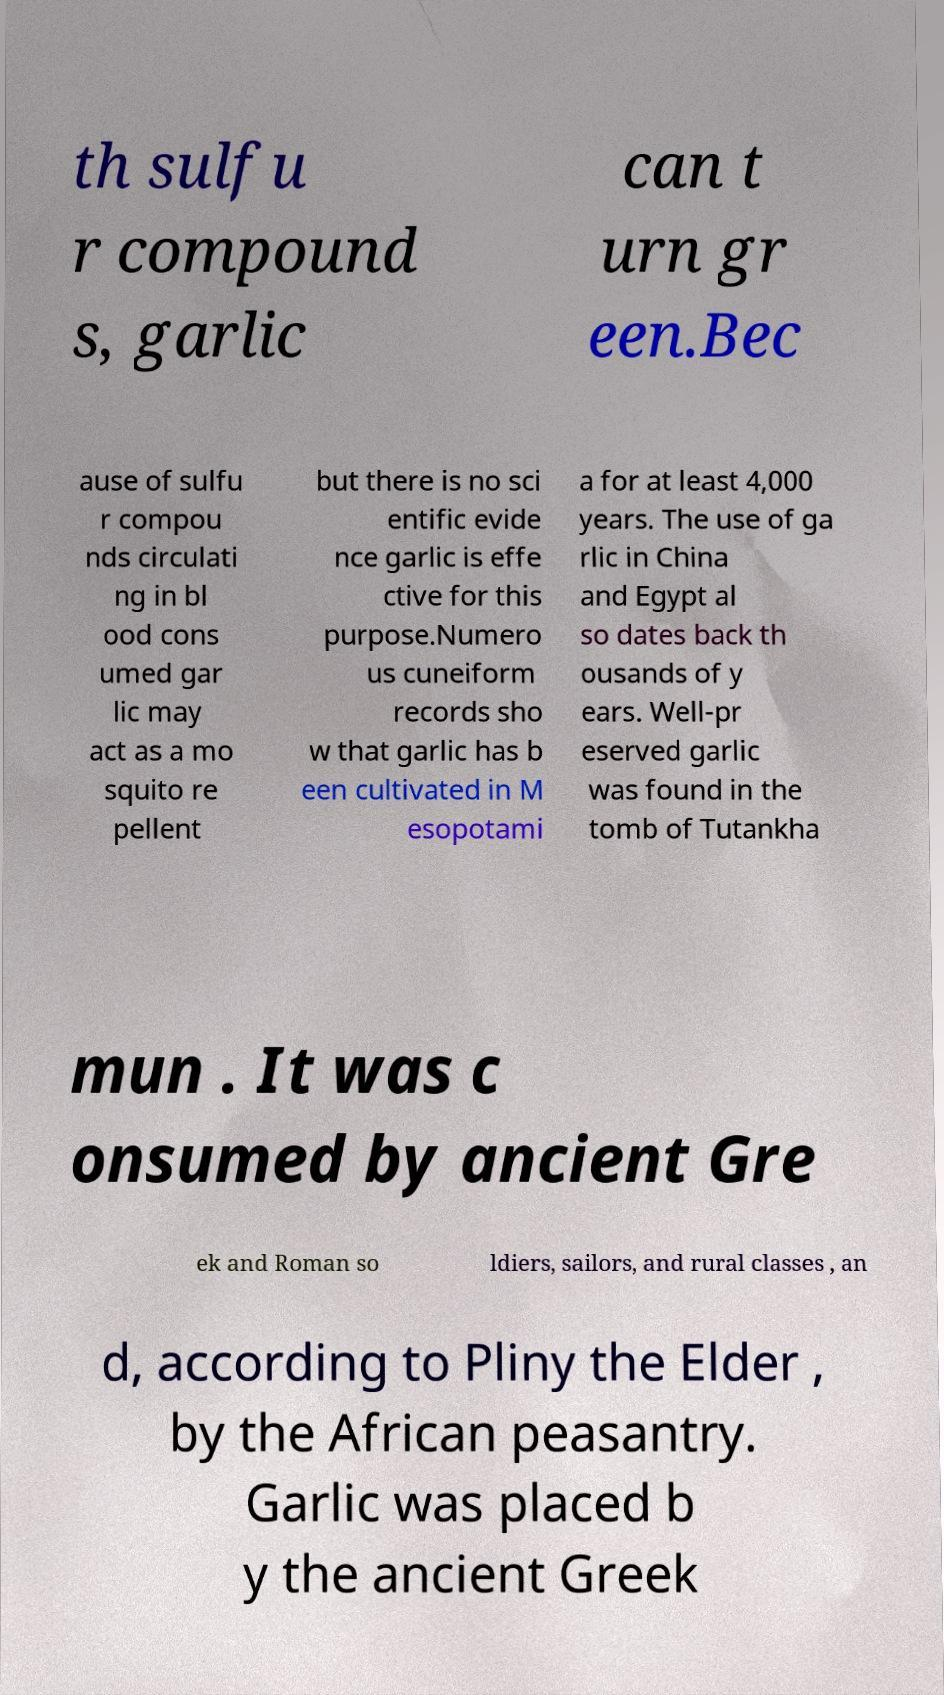I need the written content from this picture converted into text. Can you do that? th sulfu r compound s, garlic can t urn gr een.Bec ause of sulfu r compou nds circulati ng in bl ood cons umed gar lic may act as a mo squito re pellent but there is no sci entific evide nce garlic is effe ctive for this purpose.Numero us cuneiform records sho w that garlic has b een cultivated in M esopotami a for at least 4,000 years. The use of ga rlic in China and Egypt al so dates back th ousands of y ears. Well-pr eserved garlic was found in the tomb of Tutankha mun . It was c onsumed by ancient Gre ek and Roman so ldiers, sailors, and rural classes , an d, according to Pliny the Elder , by the African peasantry. Garlic was placed b y the ancient Greek 